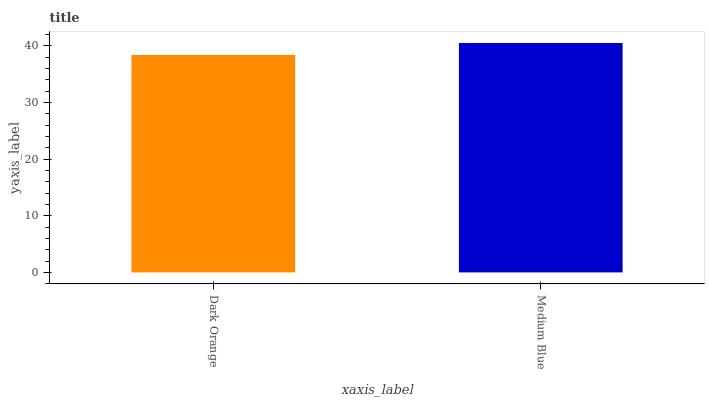Is Dark Orange the minimum?
Answer yes or no. Yes. Is Medium Blue the maximum?
Answer yes or no. Yes. Is Medium Blue the minimum?
Answer yes or no. No. Is Medium Blue greater than Dark Orange?
Answer yes or no. Yes. Is Dark Orange less than Medium Blue?
Answer yes or no. Yes. Is Dark Orange greater than Medium Blue?
Answer yes or no. No. Is Medium Blue less than Dark Orange?
Answer yes or no. No. Is Medium Blue the high median?
Answer yes or no. Yes. Is Dark Orange the low median?
Answer yes or no. Yes. Is Dark Orange the high median?
Answer yes or no. No. Is Medium Blue the low median?
Answer yes or no. No. 